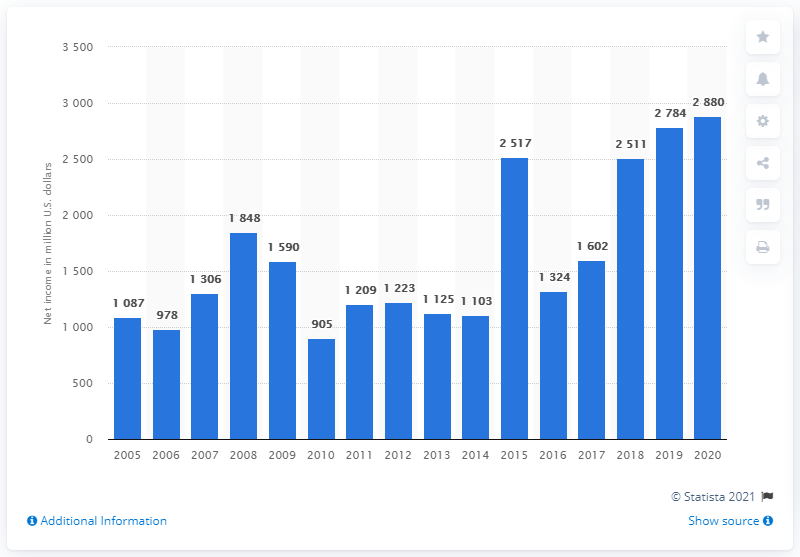Mention a couple of crucial points in this snapshot. Shin-Etsu's net income by 2020 was 2,880. In 2005, Shin-Etsu's net income was 1087. 